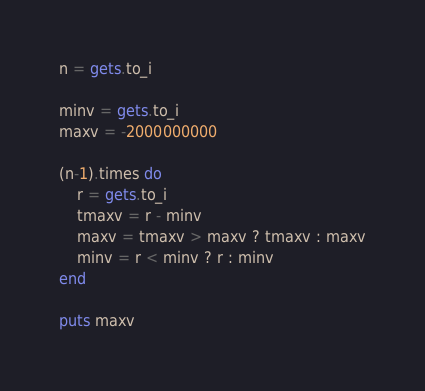Convert code to text. <code><loc_0><loc_0><loc_500><loc_500><_Ruby_>n = gets.to_i

minv = gets.to_i
maxv = -2000000000

(n-1).times do
	r = gets.to_i
	tmaxv = r - minv
	maxv = tmaxv > maxv ? tmaxv : maxv
	minv = r < minv ? r : minv
end

puts maxv</code> 